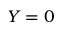Convert formula to latex. <formula><loc_0><loc_0><loc_500><loc_500>Y = 0</formula> 